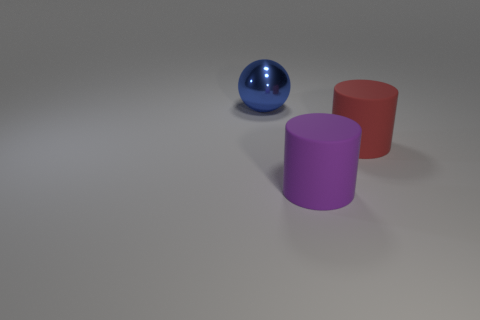What number of large red matte objects are on the left side of the blue object?
Offer a terse response. 0. Are there any purple objects made of the same material as the ball?
Make the answer very short. No. Is the number of large purple cylinders that are behind the blue metallic ball greater than the number of big purple cylinders that are on the right side of the red matte thing?
Your answer should be very brief. No. What size is the blue metal thing?
Keep it short and to the point. Large. There is a blue thing behind the red matte cylinder; what is its shape?
Give a very brief answer. Sphere. Do the large metallic object and the big red matte object have the same shape?
Provide a short and direct response. No. Is the number of blue metallic spheres that are in front of the blue metallic object the same as the number of blue rubber objects?
Provide a succinct answer. Yes. The purple rubber object has what shape?
Make the answer very short. Cylinder. Are there any other things that have the same color as the big ball?
Make the answer very short. No. There is a matte cylinder that is to the right of the purple rubber cylinder; is its size the same as the thing in front of the big red object?
Your answer should be very brief. Yes. 